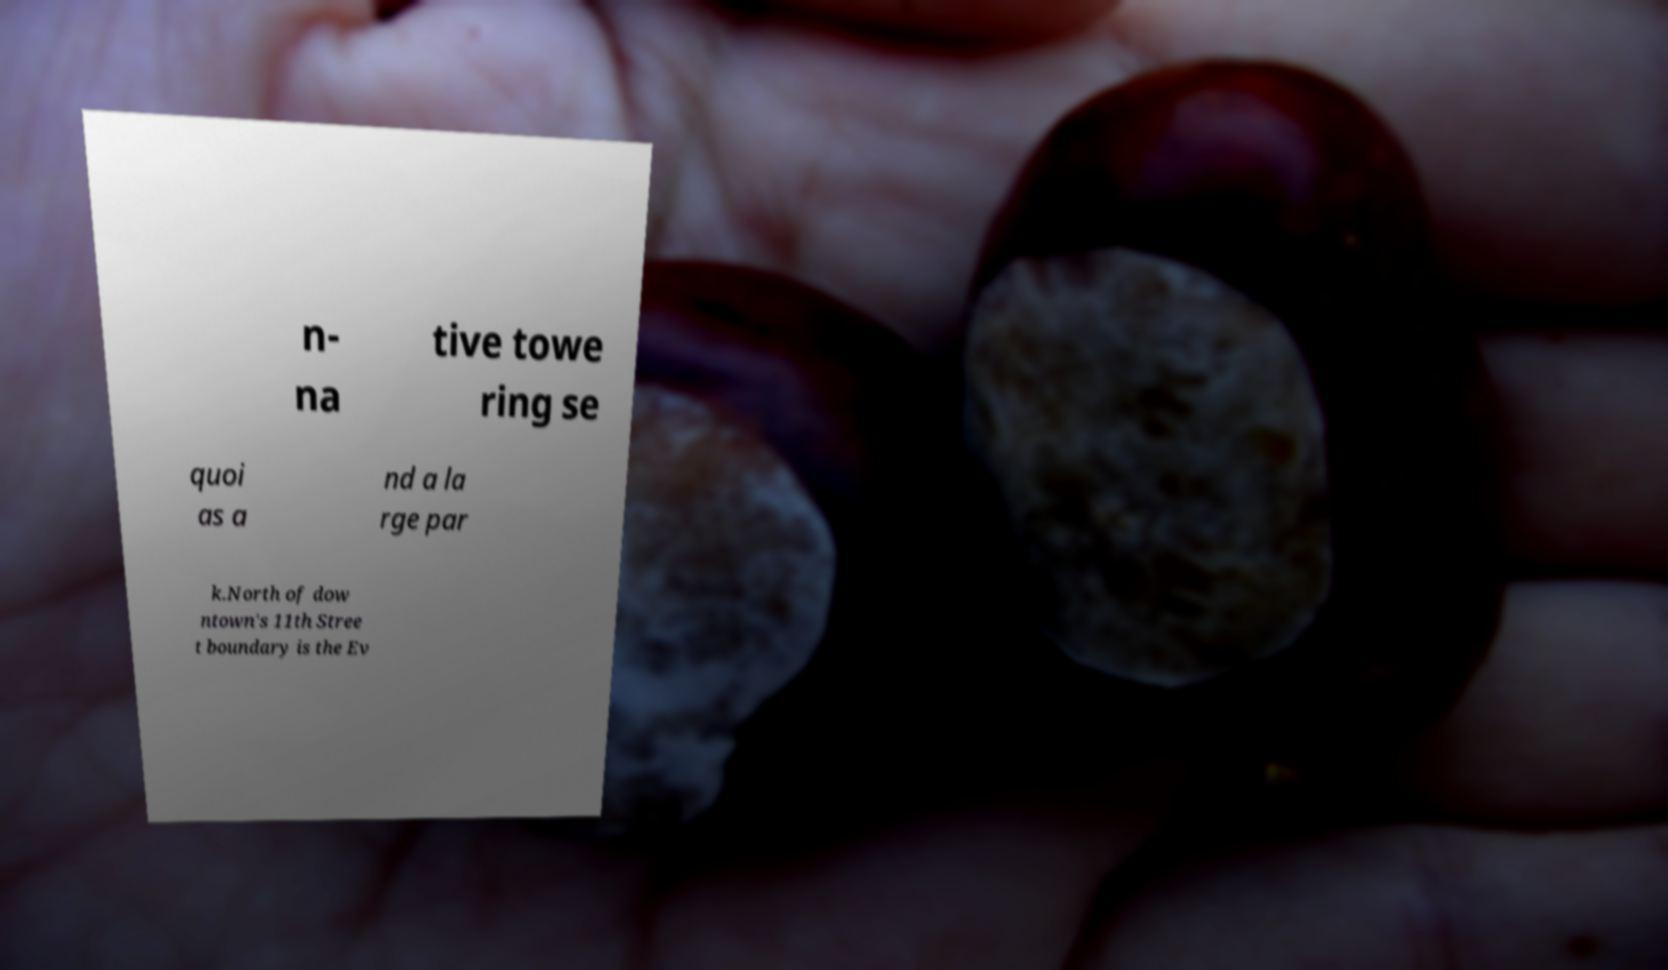Could you assist in decoding the text presented in this image and type it out clearly? n- na tive towe ring se quoi as a nd a la rge par k.North of dow ntown's 11th Stree t boundary is the Ev 